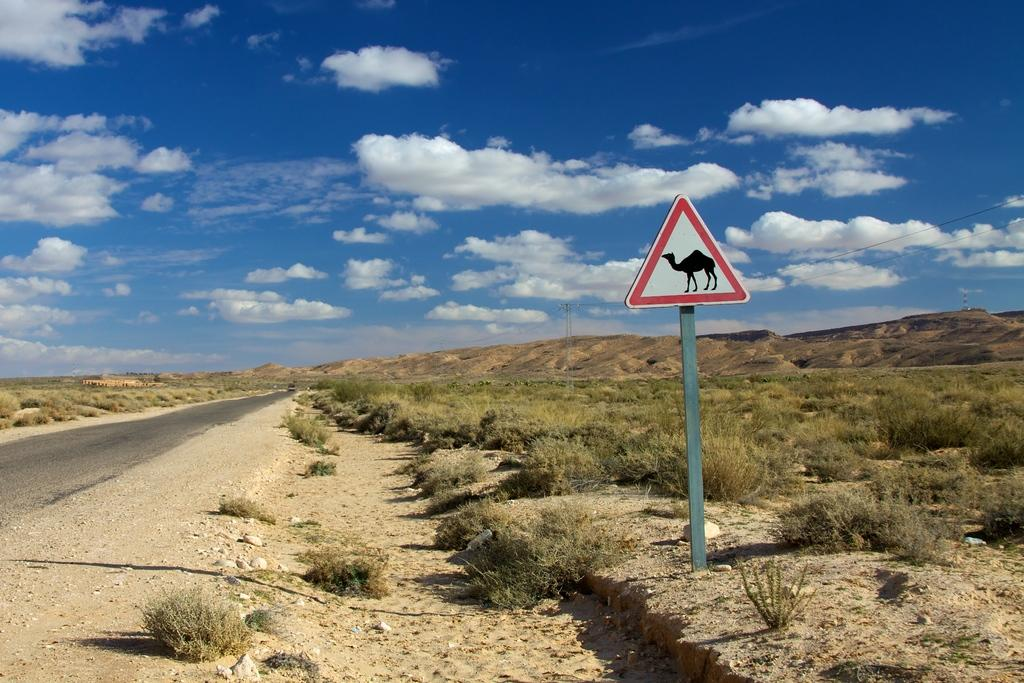What type of natural elements can be seen in the image? There are trees and plants in the image. What type of geographical feature is visible in the image? There are mountains in the image. What object is attached to a pole in the image? There is a pole with a board in the image. What type of game is being played by the doctor with a rose in the image? There is no game, doctor, or rose present in the image. 